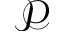Convert formula to latex. <formula><loc_0><loc_0><loc_500><loc_500>\mathcal { P }</formula> 